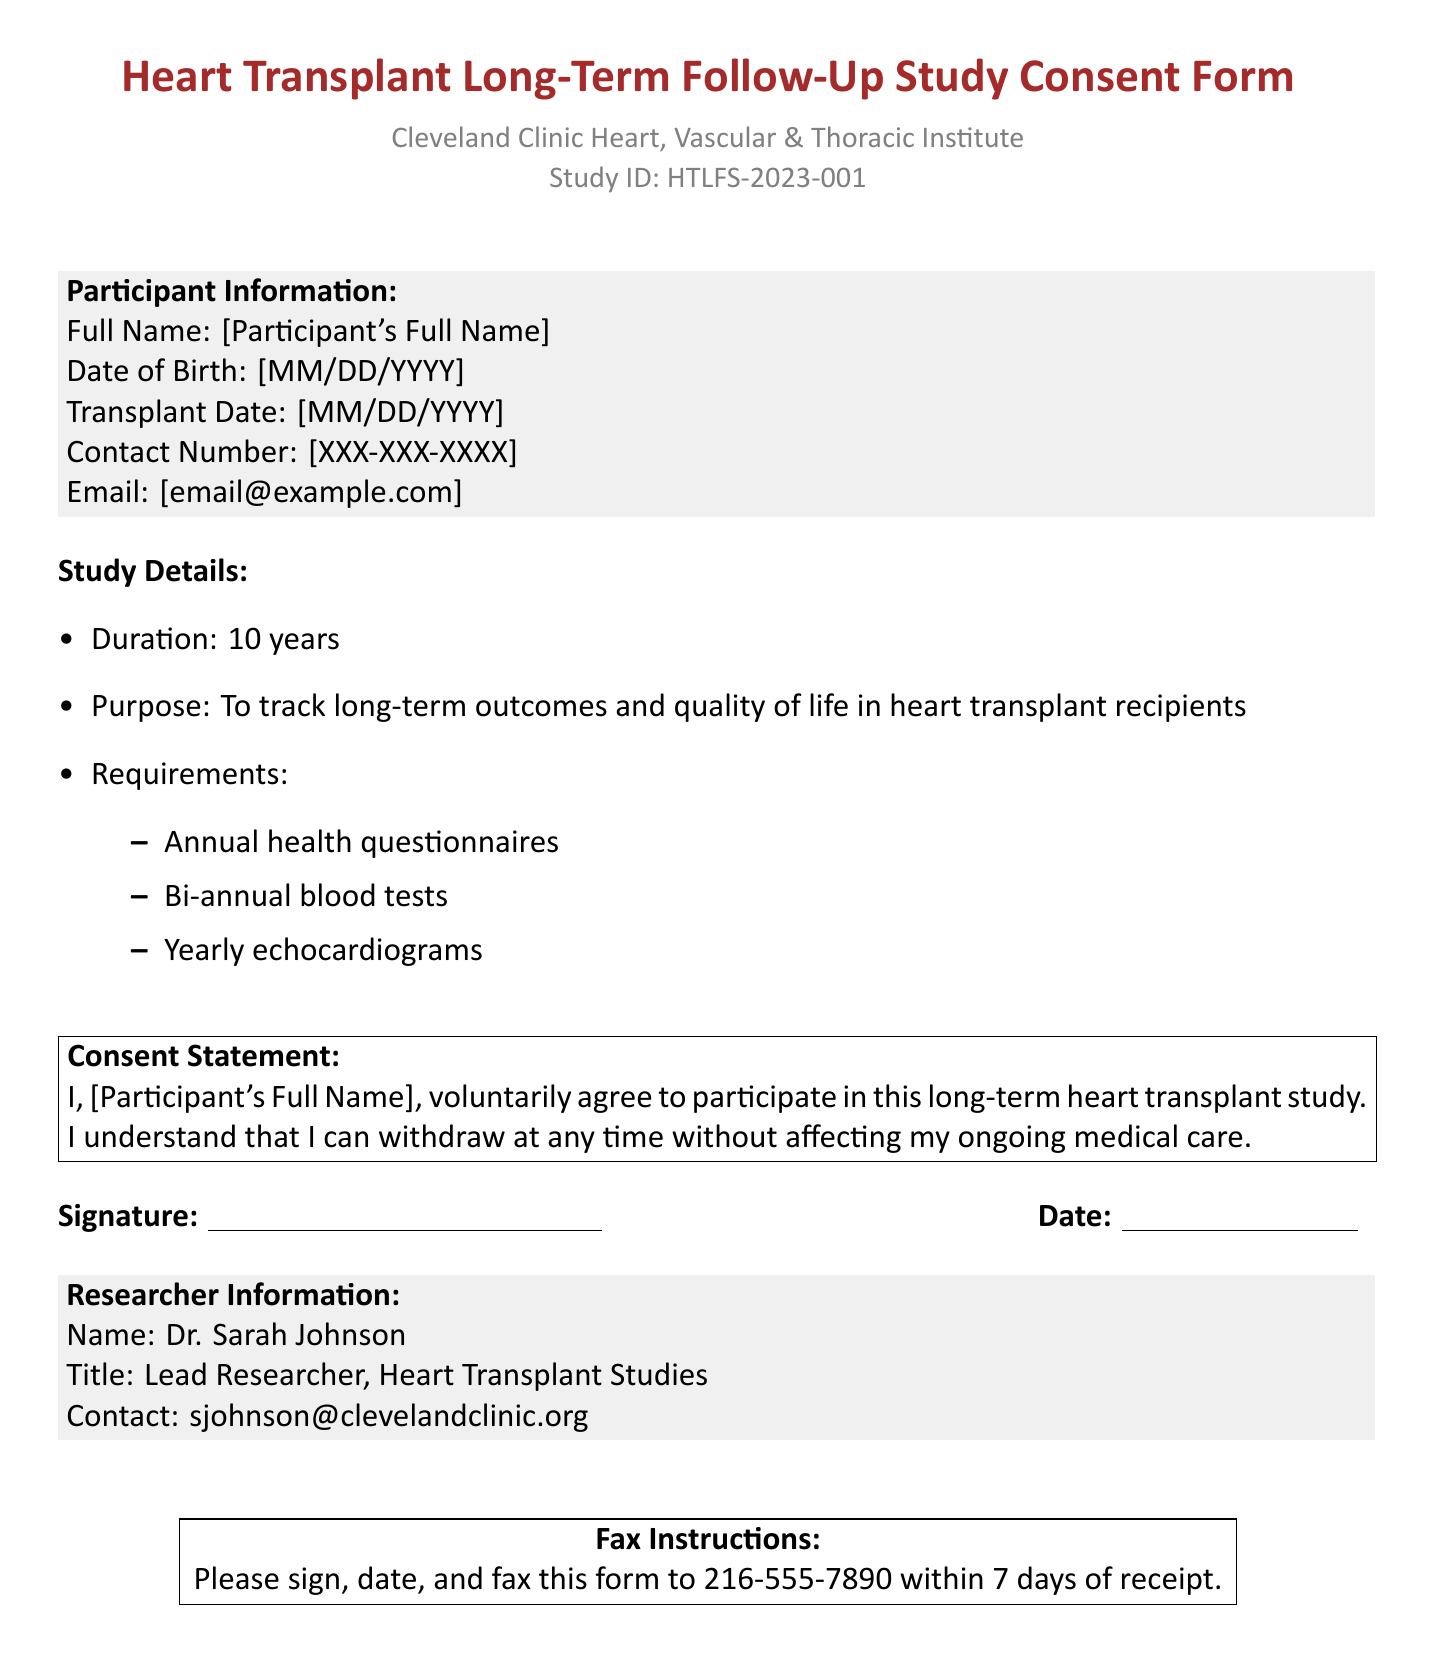What is the study ID? The study ID is a unique identifier for the study stated in the document.
Answer: HTLFS-2023-001 Who is the lead researcher? The lead researcher's name is provided in the document under Researcher Information.
Answer: Dr. Sarah Johnson What is the duration of the study? The duration of the study is explicitly mentioned in the document.
Answer: 10 years What are the annual requirements for participants? The requirements include various health checks, which are listed under Study Details.
Answer: Annual health questionnaires When must the signed form be faxed? The document specifies a timeline for faxing the signed form.
Answer: within 7 days of receipt Can participants withdraw from the study? The consent statement indicates participants' rights regarding their participation.
Answer: Yes What is the contact method for the researcher? The document provides a method to contact the researcher for inquiries.
Answer: email What is the purpose of the study? The document outlines the purpose of the study in the details provided after the duration.
Answer: To track long-term outcomes and quality of life in heart transplant recipients 